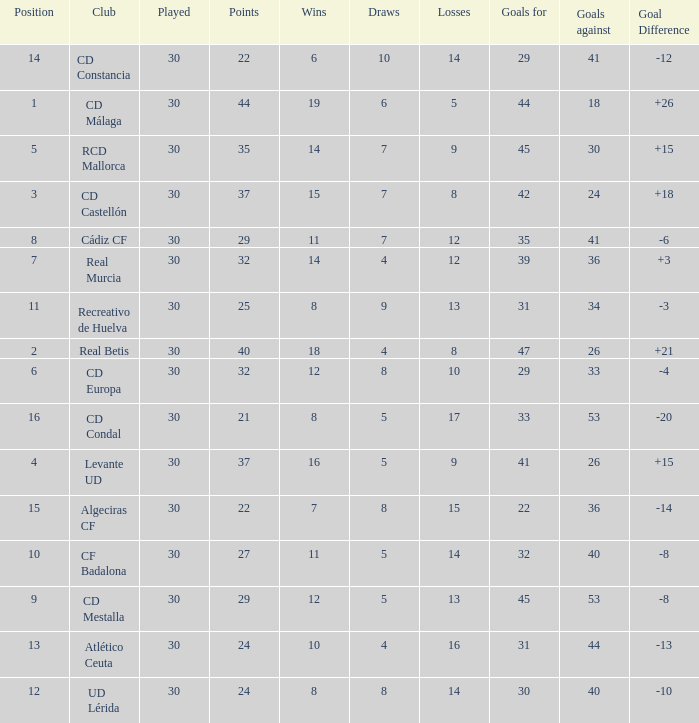What is the losses when the goal difference is larger than 26? None. 